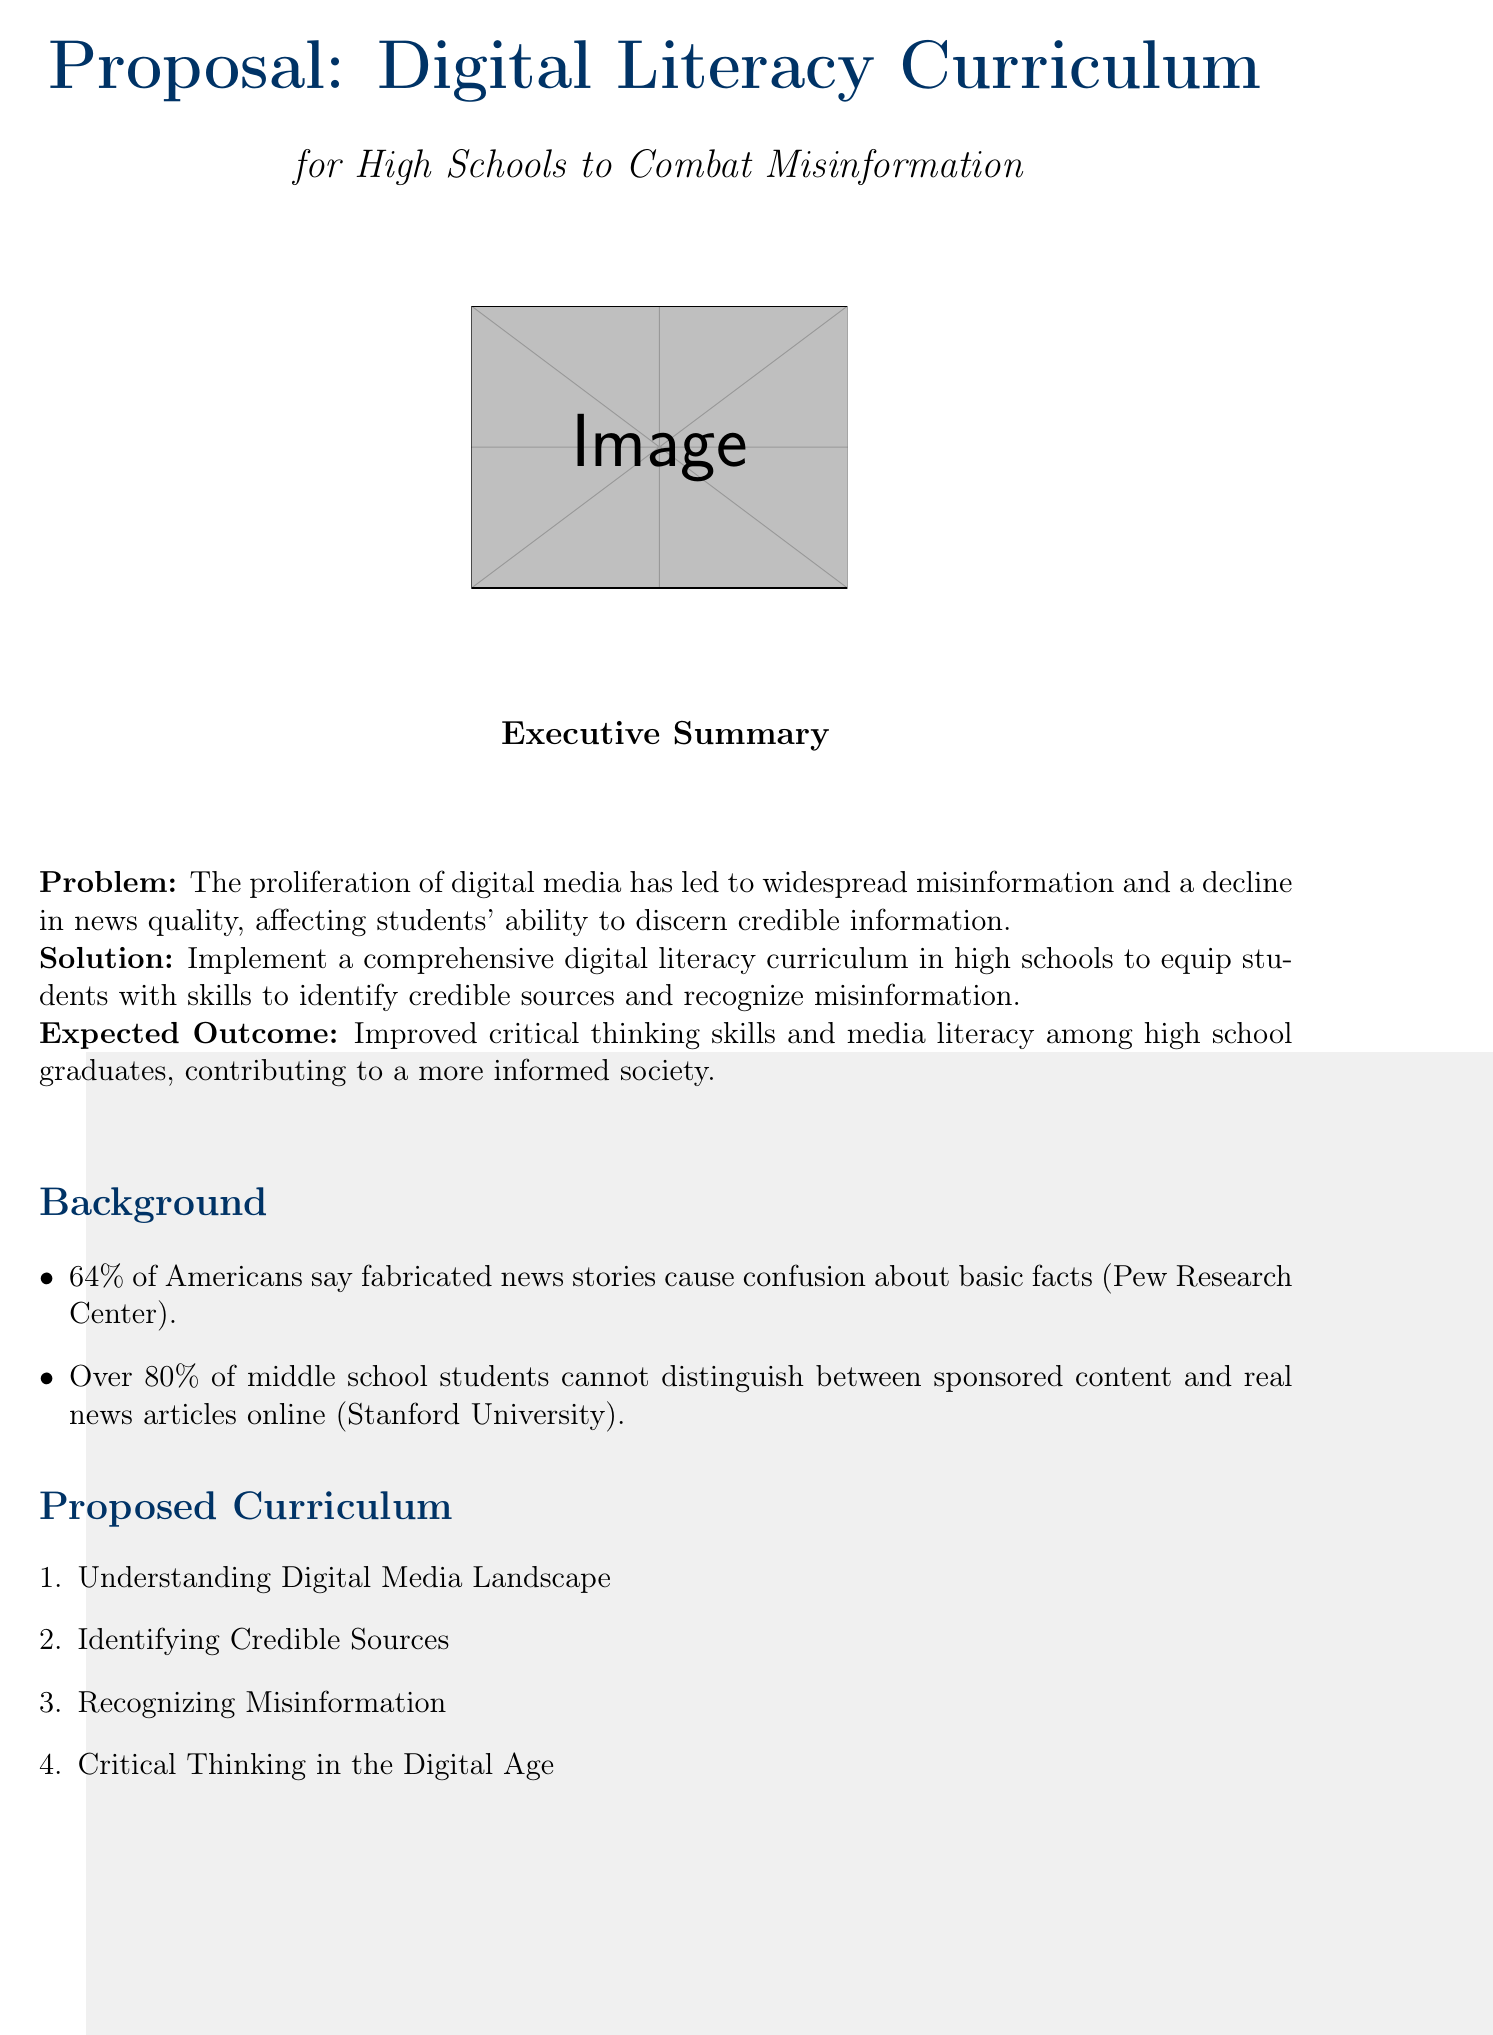What is the main problem addressed in the memo? The main problem is that the proliferation of digital media has led to widespread misinformation and a decline in news quality, affecting students' ability to discern credible information.
Answer: Misinformation What percentage of Americans say fabricated news stories cause confusion? This statistic provides context for the extent of the misinformation problem, which is supported by research data in the document.
Answer: 64% What organization collaborated with the Poynter Institute for teacher training? This information indicates a partnership aimed at improving educator skills in teaching digital literacy.
Answer: Poynter Institute What are the three modules included in the proposed curriculum? Identifying the components of the proposed curriculum helps understand how it aims to address misinformation and improve media literacy.
Answer: Understanding Digital Media Landscape, Identifying Credible Sources, Recognizing Misinformation What is the expected annual cost for updates and teacher training? The ongoing costs are specified in the budget considerations, indicating financial planning for the program's sustainability.
Answer: $200,000 What is the urgency highlighted in the conclusion? The urgency emphasizes the need for immediate action to tackle misinformation in order to maintain democratic integrity.
Answer: Significant threat What percentage of middle school students cannot distinguish between sponsored content and real news? This statistic reflects the impact of misinformation on youth, showing the need for digital literacy education.
Answer: Over 80% What is the proposed initial step for implementation? The implementation strategy outlines a first step in collaboration with a media literacy organization to pilot the curriculum.
Answer: Partner with NAMLE 